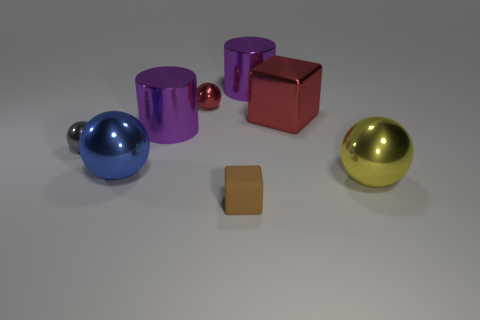Subtract 1 spheres. How many spheres are left? 3 Add 1 small red things. How many objects exist? 9 Subtract all cylinders. How many objects are left? 6 Add 4 large cubes. How many large cubes exist? 5 Subtract 0 purple spheres. How many objects are left? 8 Subtract all big yellow spheres. Subtract all yellow balls. How many objects are left? 6 Add 4 big red metallic objects. How many big red metallic objects are left? 5 